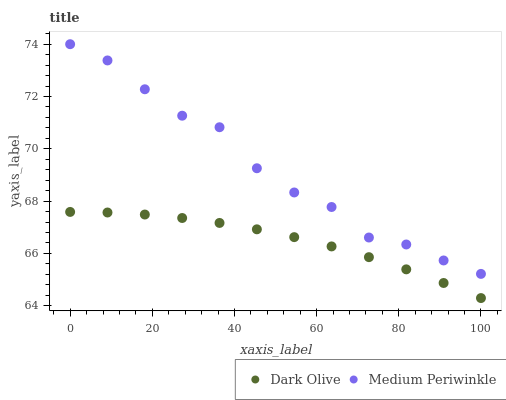Does Dark Olive have the minimum area under the curve?
Answer yes or no. Yes. Does Medium Periwinkle have the maximum area under the curve?
Answer yes or no. Yes. Does Medium Periwinkle have the minimum area under the curve?
Answer yes or no. No. Is Dark Olive the smoothest?
Answer yes or no. Yes. Is Medium Periwinkle the roughest?
Answer yes or no. Yes. Is Medium Periwinkle the smoothest?
Answer yes or no. No. Does Dark Olive have the lowest value?
Answer yes or no. Yes. Does Medium Periwinkle have the lowest value?
Answer yes or no. No. Does Medium Periwinkle have the highest value?
Answer yes or no. Yes. Is Dark Olive less than Medium Periwinkle?
Answer yes or no. Yes. Is Medium Periwinkle greater than Dark Olive?
Answer yes or no. Yes. Does Dark Olive intersect Medium Periwinkle?
Answer yes or no. No. 